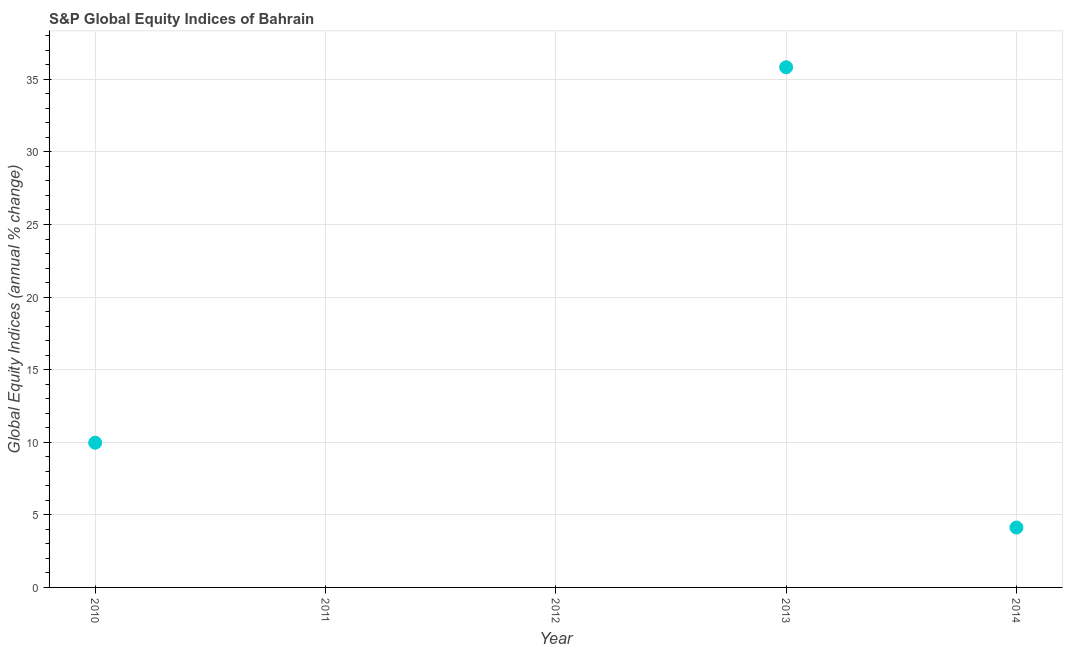Across all years, what is the maximum s&p global equity indices?
Your answer should be compact. 35.83. Across all years, what is the minimum s&p global equity indices?
Ensure brevity in your answer.  0. In which year was the s&p global equity indices maximum?
Offer a terse response. 2013. What is the sum of the s&p global equity indices?
Make the answer very short. 49.92. What is the difference between the s&p global equity indices in 2013 and 2014?
Keep it short and to the point. 31.71. What is the average s&p global equity indices per year?
Make the answer very short. 9.98. What is the median s&p global equity indices?
Provide a short and direct response. 4.13. In how many years, is the s&p global equity indices greater than 7 %?
Keep it short and to the point. 2. What is the ratio of the s&p global equity indices in 2010 to that in 2013?
Ensure brevity in your answer.  0.28. Is the difference between the s&p global equity indices in 2010 and 2013 greater than the difference between any two years?
Make the answer very short. No. What is the difference between the highest and the second highest s&p global equity indices?
Offer a terse response. 25.86. Is the sum of the s&p global equity indices in 2010 and 2014 greater than the maximum s&p global equity indices across all years?
Provide a succinct answer. No. What is the difference between the highest and the lowest s&p global equity indices?
Your answer should be compact. 35.83. Does the s&p global equity indices monotonically increase over the years?
Offer a terse response. No. How many dotlines are there?
Your answer should be very brief. 1. What is the difference between two consecutive major ticks on the Y-axis?
Provide a short and direct response. 5. Are the values on the major ticks of Y-axis written in scientific E-notation?
Offer a very short reply. No. Does the graph contain any zero values?
Your answer should be very brief. Yes. Does the graph contain grids?
Make the answer very short. Yes. What is the title of the graph?
Make the answer very short. S&P Global Equity Indices of Bahrain. What is the label or title of the X-axis?
Offer a terse response. Year. What is the label or title of the Y-axis?
Give a very brief answer. Global Equity Indices (annual % change). What is the Global Equity Indices (annual % change) in 2010?
Provide a short and direct response. 9.97. What is the Global Equity Indices (annual % change) in 2012?
Provide a short and direct response. 0. What is the Global Equity Indices (annual % change) in 2013?
Offer a terse response. 35.83. What is the Global Equity Indices (annual % change) in 2014?
Offer a terse response. 4.13. What is the difference between the Global Equity Indices (annual % change) in 2010 and 2013?
Your answer should be very brief. -25.86. What is the difference between the Global Equity Indices (annual % change) in 2010 and 2014?
Offer a terse response. 5.84. What is the difference between the Global Equity Indices (annual % change) in 2013 and 2014?
Your answer should be very brief. 31.71. What is the ratio of the Global Equity Indices (annual % change) in 2010 to that in 2013?
Offer a very short reply. 0.28. What is the ratio of the Global Equity Indices (annual % change) in 2010 to that in 2014?
Make the answer very short. 2.42. What is the ratio of the Global Equity Indices (annual % change) in 2013 to that in 2014?
Give a very brief answer. 8.69. 